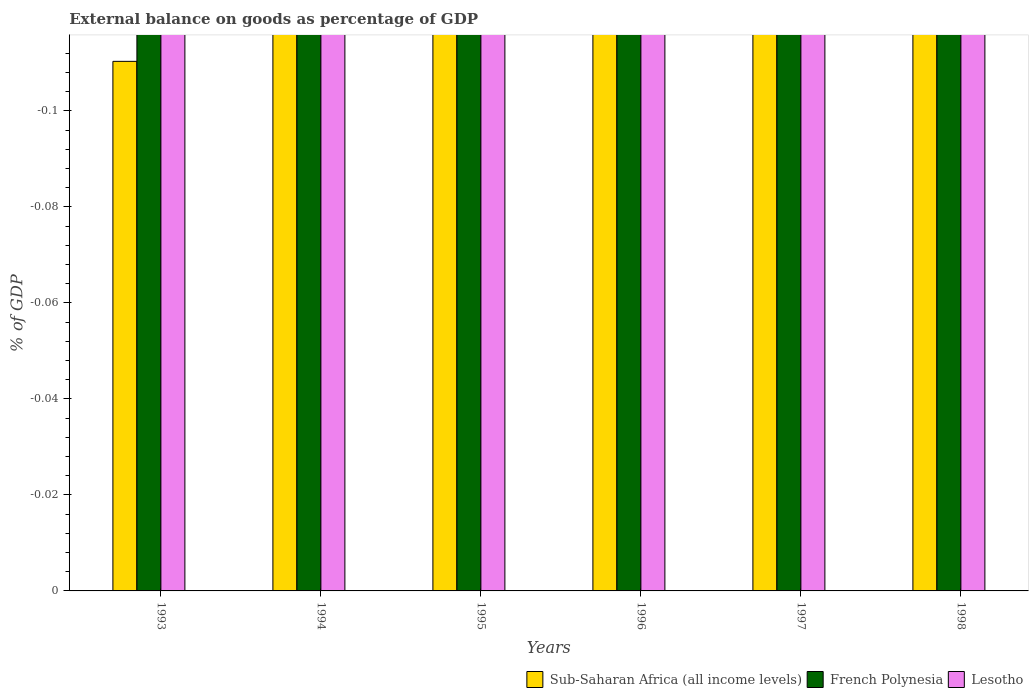In how many cases, is the number of bars for a given year not equal to the number of legend labels?
Your response must be concise. 6. Across all years, what is the minimum external balance on goods as percentage of GDP in Sub-Saharan Africa (all income levels)?
Offer a terse response. 0. What is the total external balance on goods as percentage of GDP in French Polynesia in the graph?
Offer a very short reply. 0. What is the difference between the external balance on goods as percentage of GDP in French Polynesia in 1993 and the external balance on goods as percentage of GDP in Lesotho in 1995?
Provide a short and direct response. 0. In how many years, is the external balance on goods as percentage of GDP in Sub-Saharan Africa (all income levels) greater than the average external balance on goods as percentage of GDP in Sub-Saharan Africa (all income levels) taken over all years?
Keep it short and to the point. 0. Is it the case that in every year, the sum of the external balance on goods as percentage of GDP in French Polynesia and external balance on goods as percentage of GDP in Sub-Saharan Africa (all income levels) is greater than the external balance on goods as percentage of GDP in Lesotho?
Keep it short and to the point. No. How many years are there in the graph?
Provide a short and direct response. 6. What is the difference between two consecutive major ticks on the Y-axis?
Keep it short and to the point. 0.02. Are the values on the major ticks of Y-axis written in scientific E-notation?
Ensure brevity in your answer.  No. Where does the legend appear in the graph?
Give a very brief answer. Bottom right. How are the legend labels stacked?
Keep it short and to the point. Horizontal. What is the title of the graph?
Make the answer very short. External balance on goods as percentage of GDP. Does "Sweden" appear as one of the legend labels in the graph?
Make the answer very short. No. What is the label or title of the Y-axis?
Offer a very short reply. % of GDP. What is the % of GDP in Sub-Saharan Africa (all income levels) in 1993?
Offer a terse response. 0. What is the % of GDP in French Polynesia in 1993?
Provide a short and direct response. 0. What is the % of GDP in Sub-Saharan Africa (all income levels) in 1995?
Make the answer very short. 0. What is the % of GDP of Lesotho in 1995?
Provide a short and direct response. 0. What is the % of GDP of Sub-Saharan Africa (all income levels) in 1996?
Ensure brevity in your answer.  0. What is the % of GDP in Lesotho in 1996?
Keep it short and to the point. 0. What is the % of GDP in French Polynesia in 1998?
Ensure brevity in your answer.  0. What is the total % of GDP in French Polynesia in the graph?
Your response must be concise. 0. What is the total % of GDP of Lesotho in the graph?
Your answer should be very brief. 0. What is the average % of GDP in Sub-Saharan Africa (all income levels) per year?
Offer a very short reply. 0. What is the average % of GDP of Lesotho per year?
Your answer should be very brief. 0. 